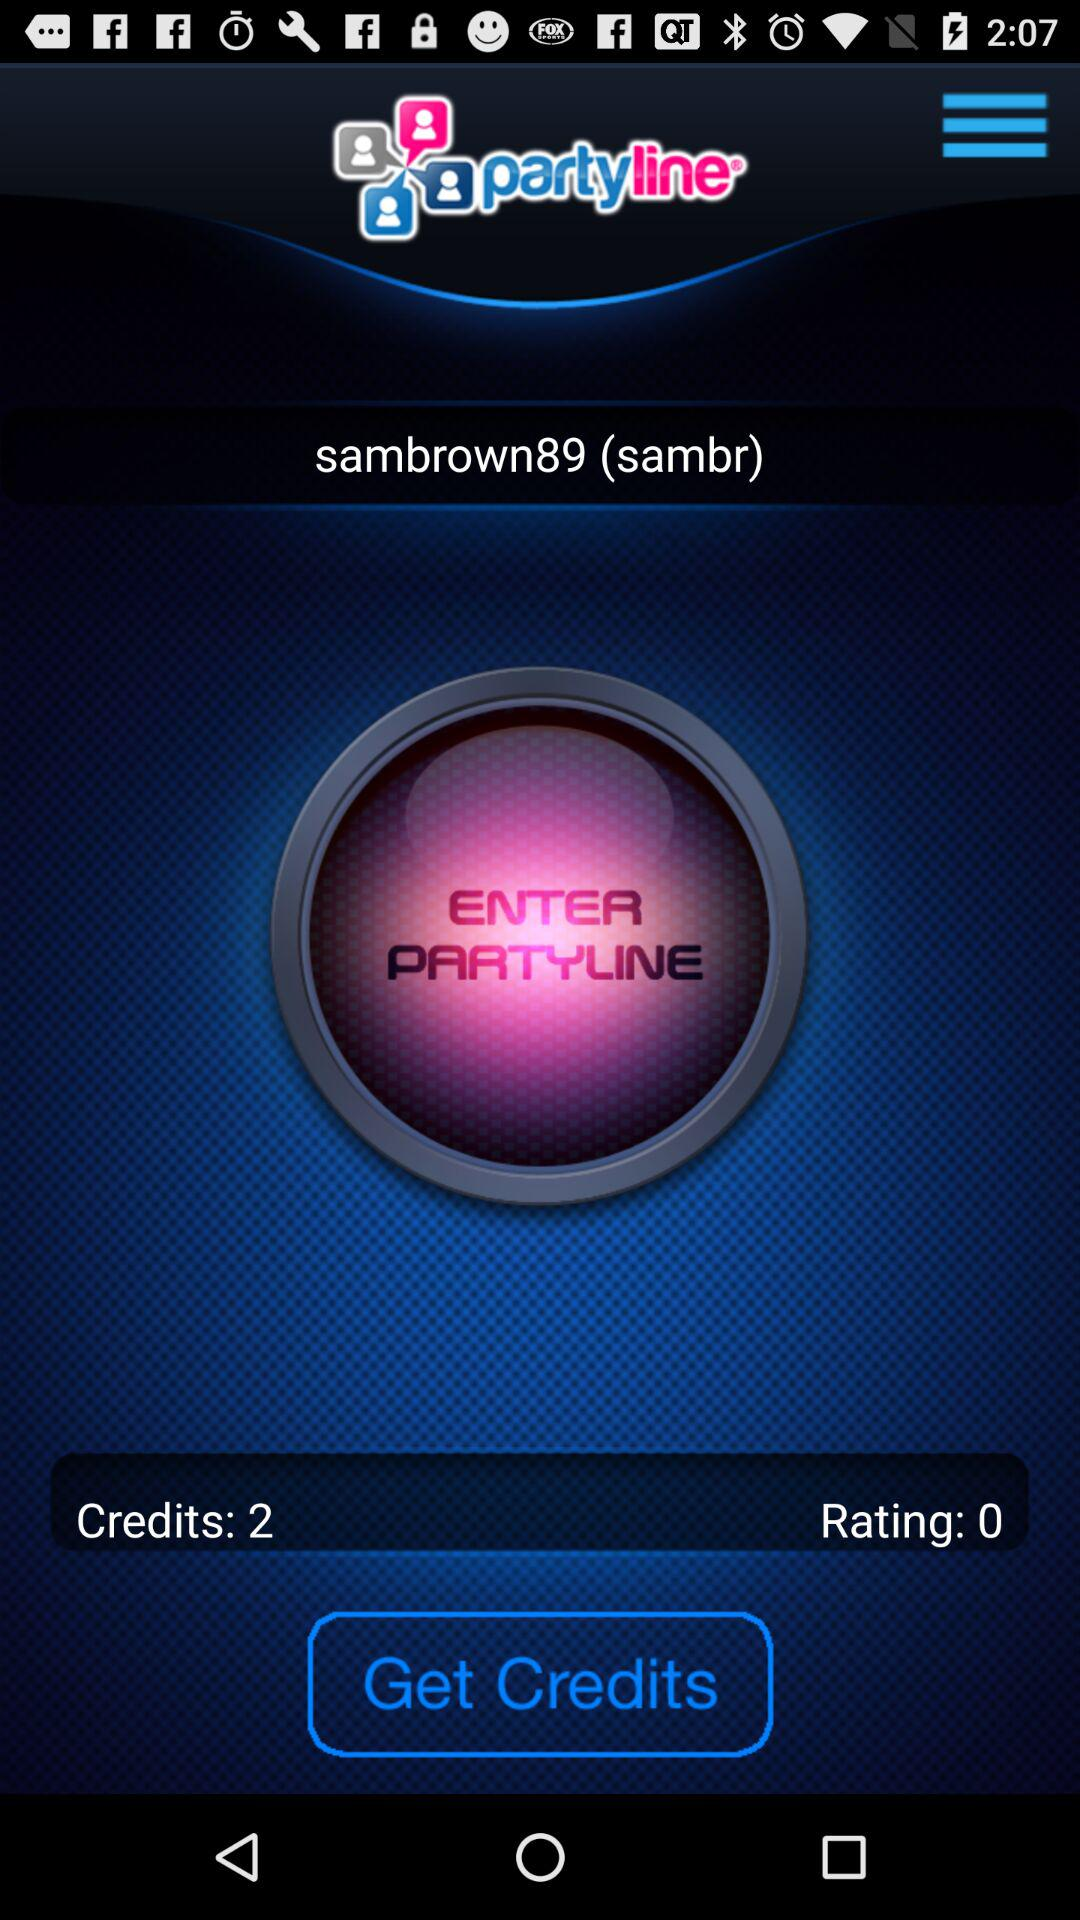What is the application name? The application name is "partyline". 